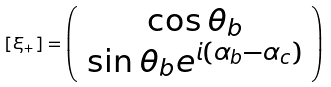<formula> <loc_0><loc_0><loc_500><loc_500>[ \xi _ { + } ] = \left ( \begin{array} { c } \cos \theta _ { b } \\ \sin \theta _ { b } e ^ { i ( \alpha _ { b } - \alpha _ { c } ) } \end{array} \right )</formula> 